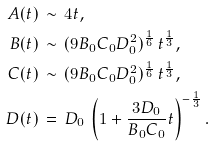<formula> <loc_0><loc_0><loc_500><loc_500>A ( t ) \, & \sim \, 4 t , \\ B ( t ) \, & \sim \, ( 9 B _ { 0 } C _ { 0 } D _ { 0 } ^ { 2 } ) ^ { \frac { 1 } { 6 } } \, t ^ { \frac { 1 } { 3 } } , \\ C ( t ) \, & \sim \, ( 9 B _ { 0 } C _ { 0 } D _ { 0 } ^ { 2 } ) ^ { \frac { 1 } { 6 } } \, t ^ { \frac { 1 } { 3 } } , \\ D ( t ) \, & = \, D _ { 0 } \, \left ( 1 + \frac { 3 D _ { 0 } } { B _ { 0 } C _ { 0 } } t \right ) ^ { - \frac { 1 } { 3 } } .</formula> 